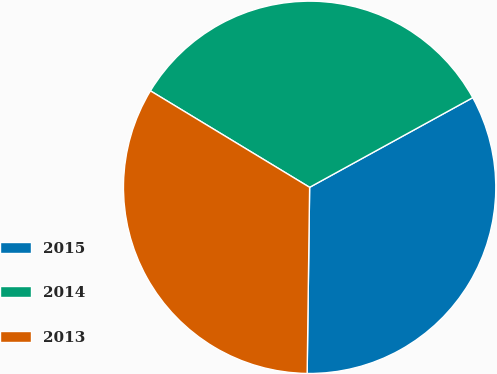<chart> <loc_0><loc_0><loc_500><loc_500><pie_chart><fcel>2015<fcel>2014<fcel>2013<nl><fcel>33.21%<fcel>33.33%<fcel>33.46%<nl></chart> 